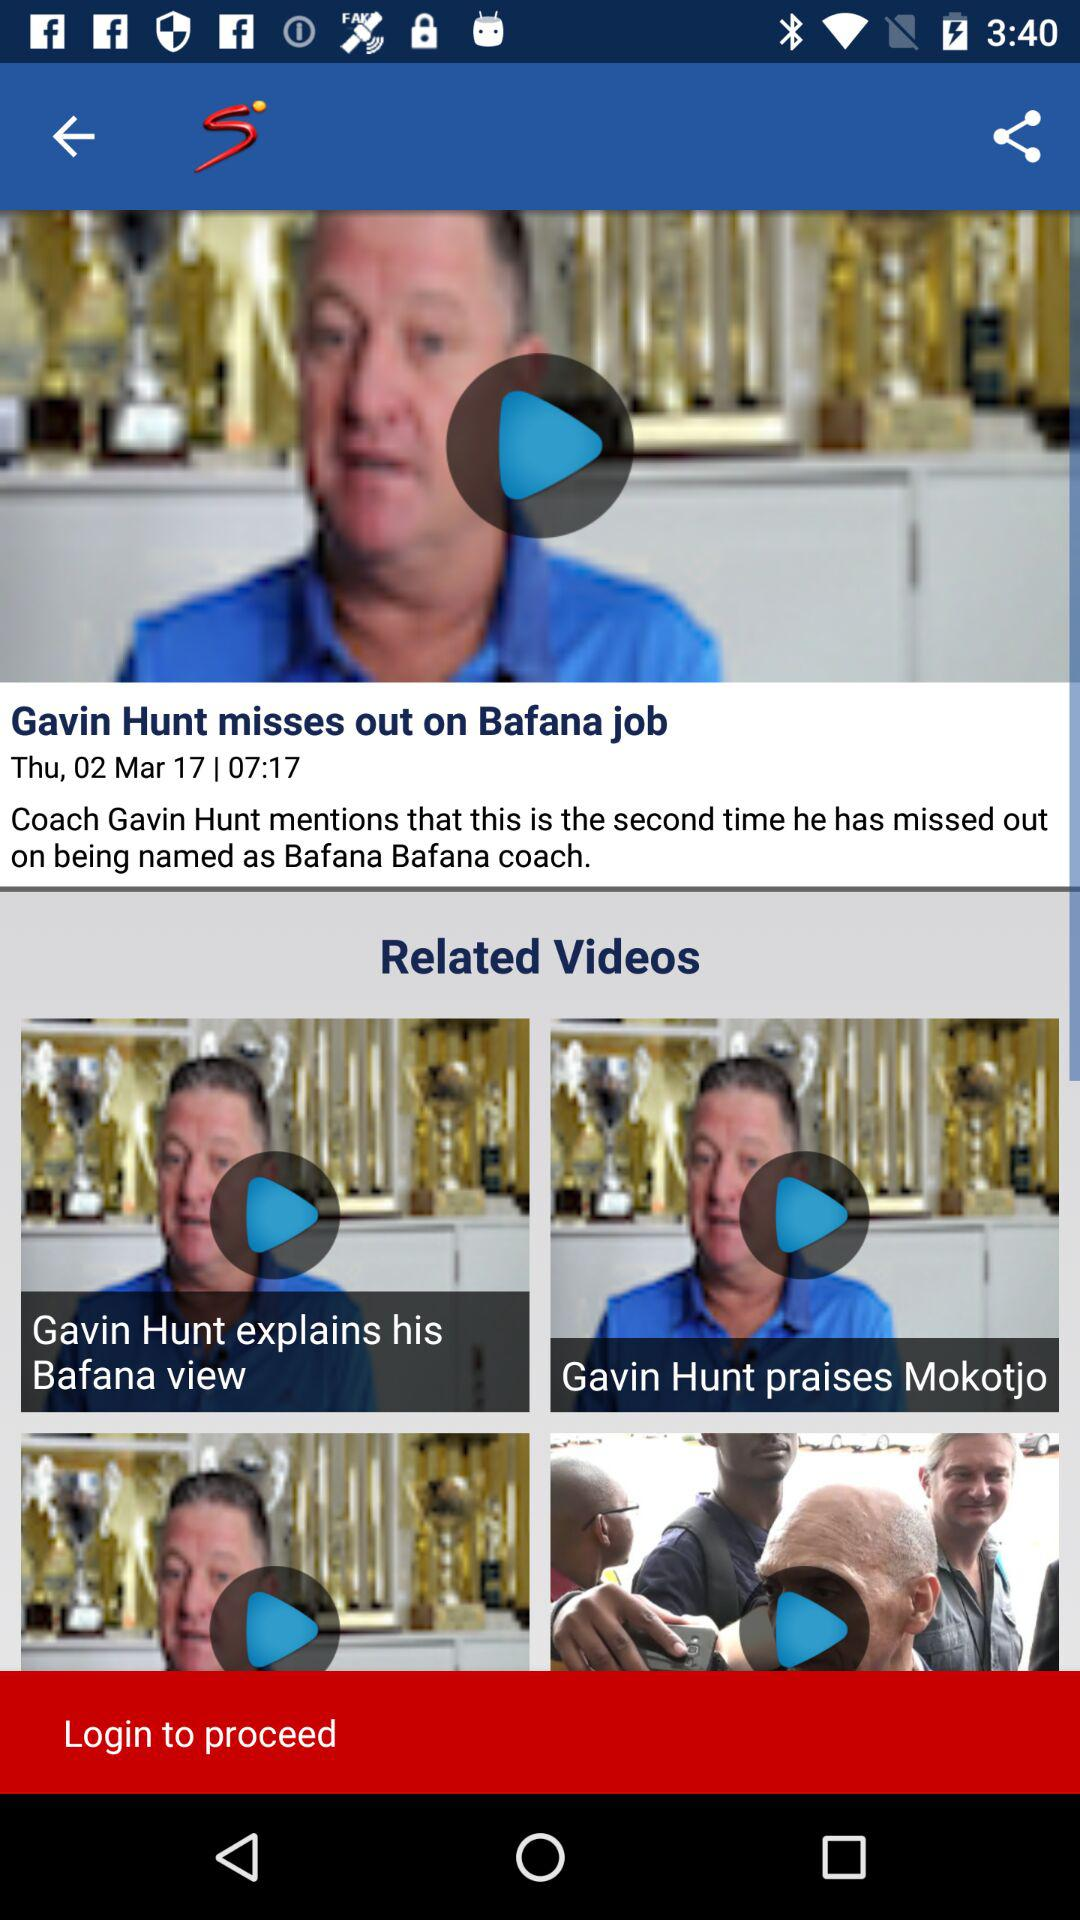What day is March 2?
Answer the question using a single word or phrase. It is Thursday. 